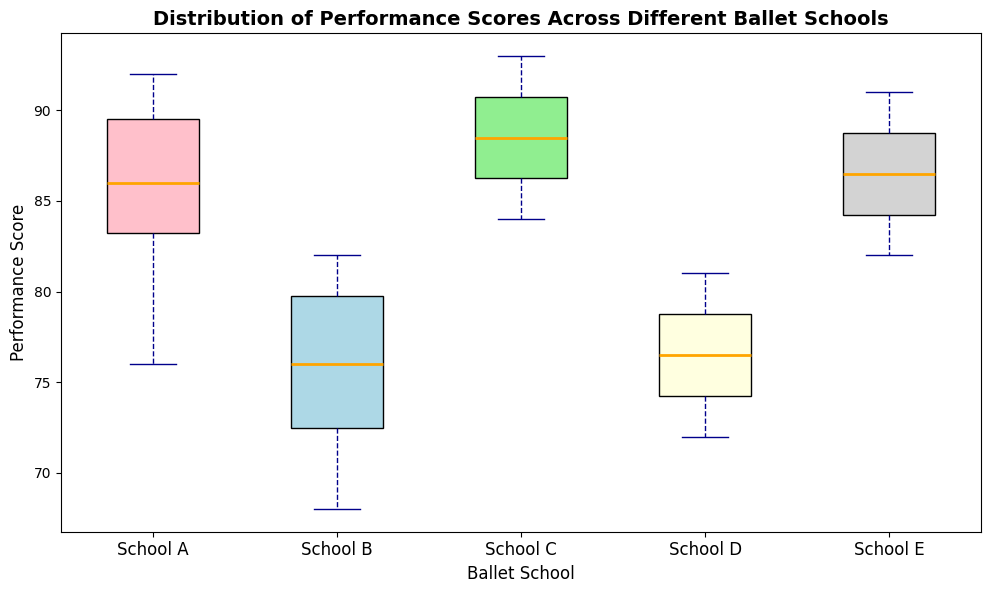Which ballet school has the highest median performance score? Look at the middle line in each box plot, which represents the median. Identify the highest median line among the school box plots.
Answer: School E Which ballet school has the widest range of performance scores? Compare the lengths of the box plots' whiskers for each school. The wider the range, the longer the whiskers.
Answer: School B How does the median performance score of School C compare to that of School D? Compare the median lines in the box plots of School C and School D. The median of School C is higher than that of School D.
Answer: Higher Which ballet school has the smallest interquartile range (IQR)? The IQR is represented by the box itself (the distance between the 25th and 75th percentiles). Look for the shortest box.
Answer: School D Does any ballet school have any outliers? Outliers are represented by dots outside the whiskers. Check if any school has these dots.
Answer: No Is the median performance score of School A higher or lower than that of School B? Compare the median lines in the box plots of School A and School B. The median of School A is higher than that of School B.
Answer: Higher What is the color of the box plot for School E, and what does that indicate? School E's box plot is in lightgrey. The color is used merely to distinguish between different schools, not to indicate any specific data value.
Answer: Lightgrey Which ballet school has the most consistent performance scores? Consistency is represented by a smaller IQR and shorter whiskers. Check which school has the smallest total spread.
Answer: School D 